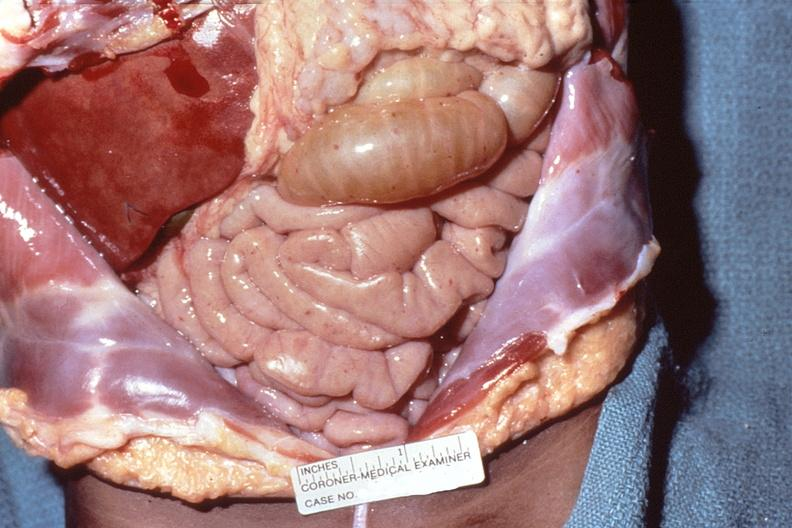s abdomen present?
Answer the question using a single word or phrase. Yes 